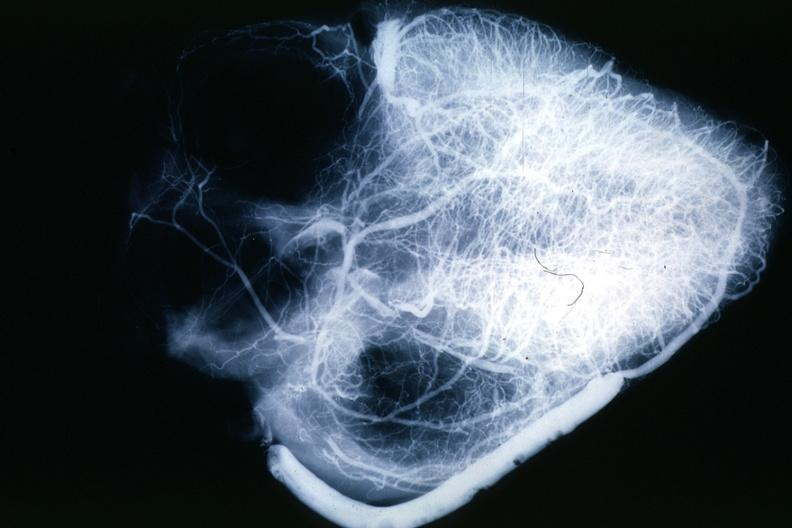what left ventricles?
Answer the question using a single word or phrase. X-ray postmortinjection showing vein anastomosis very well and the vasculature of the right and 